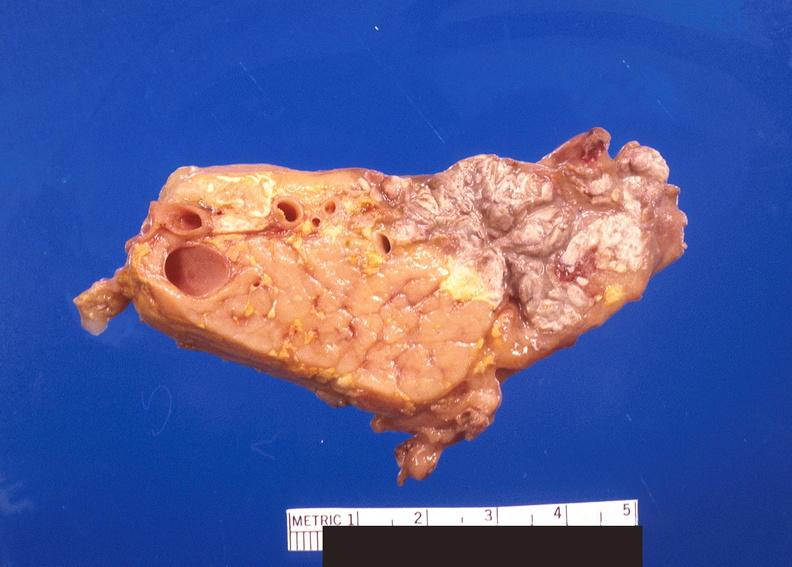does this image show pancreatic fat necrosis?
Answer the question using a single word or phrase. Yes 